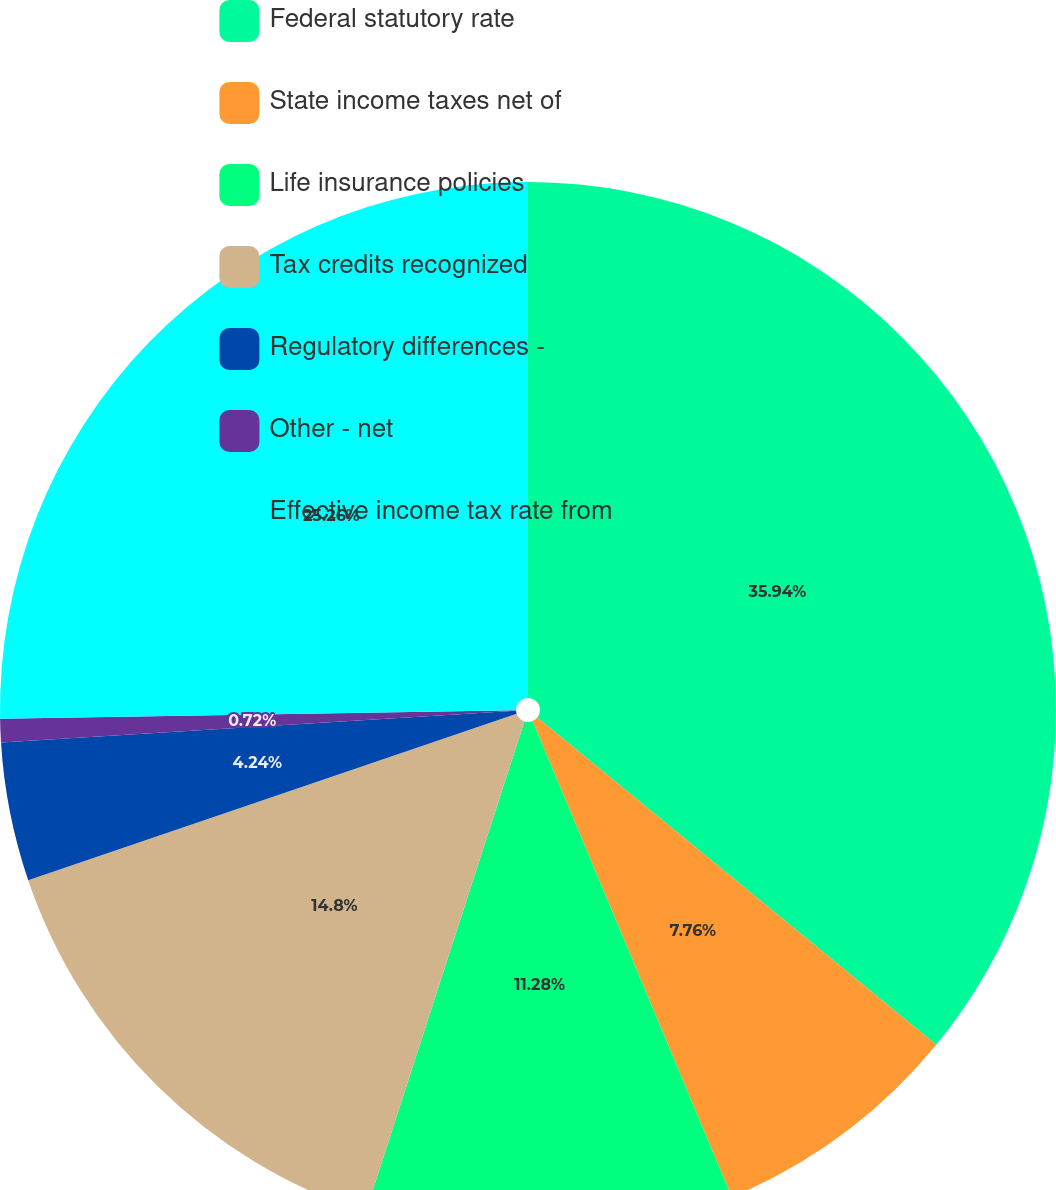<chart> <loc_0><loc_0><loc_500><loc_500><pie_chart><fcel>Federal statutory rate<fcel>State income taxes net of<fcel>Life insurance policies<fcel>Tax credits recognized<fcel>Regulatory differences -<fcel>Other - net<fcel>Effective income tax rate from<nl><fcel>35.93%<fcel>7.76%<fcel>11.28%<fcel>14.8%<fcel>4.24%<fcel>0.72%<fcel>25.26%<nl></chart> 